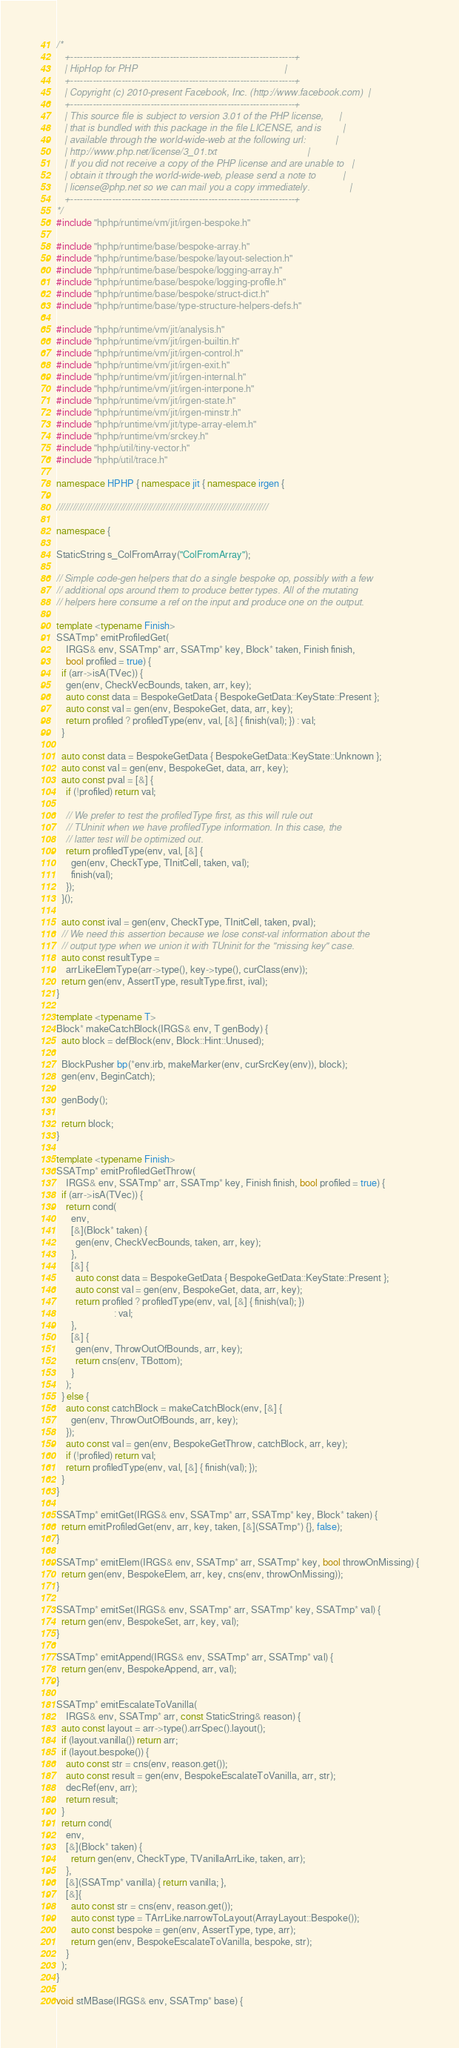<code> <loc_0><loc_0><loc_500><loc_500><_C++_>/*
   +----------------------------------------------------------------------+
   | HipHop for PHP                                                       |
   +----------------------------------------------------------------------+
   | Copyright (c) 2010-present Facebook, Inc. (http://www.facebook.com)  |
   +----------------------------------------------------------------------+
   | This source file is subject to version 3.01 of the PHP license,      |
   | that is bundled with this package in the file LICENSE, and is        |
   | available through the world-wide-web at the following url:           |
   | http://www.php.net/license/3_01.txt                                  |
   | If you did not receive a copy of the PHP license and are unable to   |
   | obtain it through the world-wide-web, please send a note to          |
   | license@php.net so we can mail you a copy immediately.               |
   +----------------------------------------------------------------------+
*/
#include "hphp/runtime/vm/jit/irgen-bespoke.h"

#include "hphp/runtime/base/bespoke-array.h"
#include "hphp/runtime/base/bespoke/layout-selection.h"
#include "hphp/runtime/base/bespoke/logging-array.h"
#include "hphp/runtime/base/bespoke/logging-profile.h"
#include "hphp/runtime/base/bespoke/struct-dict.h"
#include "hphp/runtime/base/type-structure-helpers-defs.h"

#include "hphp/runtime/vm/jit/analysis.h"
#include "hphp/runtime/vm/jit/irgen-builtin.h"
#include "hphp/runtime/vm/jit/irgen-control.h"
#include "hphp/runtime/vm/jit/irgen-exit.h"
#include "hphp/runtime/vm/jit/irgen-internal.h"
#include "hphp/runtime/vm/jit/irgen-interpone.h"
#include "hphp/runtime/vm/jit/irgen-state.h"
#include "hphp/runtime/vm/jit/irgen-minstr.h"
#include "hphp/runtime/vm/jit/type-array-elem.h"
#include "hphp/runtime/vm/srckey.h"
#include "hphp/util/tiny-vector.h"
#include "hphp/util/trace.h"

namespace HPHP { namespace jit { namespace irgen {

///////////////////////////////////////////////////////////////////////////////

namespace {

StaticString s_ColFromArray("ColFromArray");

// Simple code-gen helpers that do a single bespoke op, possibly with a few
// additional ops around them to produce better types. All of the mutating
// helpers here consume a ref on the input and produce one on the output.

template <typename Finish>
SSATmp* emitProfiledGet(
    IRGS& env, SSATmp* arr, SSATmp* key, Block* taken, Finish finish,
    bool profiled = true) {
  if (arr->isA(TVec)) {
    gen(env, CheckVecBounds, taken, arr, key);
    auto const data = BespokeGetData { BespokeGetData::KeyState::Present };
    auto const val = gen(env, BespokeGet, data, arr, key);
    return profiled ? profiledType(env, val, [&] { finish(val); }) : val;
  }

  auto const data = BespokeGetData { BespokeGetData::KeyState::Unknown };
  auto const val = gen(env, BespokeGet, data, arr, key);
  auto const pval = [&] {
    if (!profiled) return val;

    // We prefer to test the profiledType first, as this will rule out
    // TUninit when we have profiledType information. In this case, the
    // latter test will be optimized out.
    return profiledType(env, val, [&] {
      gen(env, CheckType, TInitCell, taken, val);
      finish(val);
    });
  }();

  auto const ival = gen(env, CheckType, TInitCell, taken, pval);
  // We need this assertion because we lose const-val information about the
  // output type when we union it with TUninit for the "missing key" case.
  auto const resultType =
    arrLikeElemType(arr->type(), key->type(), curClass(env));
  return gen(env, AssertType, resultType.first, ival);
}

template <typename T>
Block* makeCatchBlock(IRGS& env, T genBody) {
  auto block = defBlock(env, Block::Hint::Unused);

  BlockPusher bp(*env.irb, makeMarker(env, curSrcKey(env)), block);
  gen(env, BeginCatch);

  genBody();

  return block;
}

template <typename Finish>
SSATmp* emitProfiledGetThrow(
    IRGS& env, SSATmp* arr, SSATmp* key, Finish finish, bool profiled = true) {
  if (arr->isA(TVec)) {
    return cond(
      env,
      [&](Block* taken) {
        gen(env, CheckVecBounds, taken, arr, key);
      },
      [&] {
        auto const data = BespokeGetData { BespokeGetData::KeyState::Present };
        auto const val = gen(env, BespokeGet, data, arr, key);
        return profiled ? profiledType(env, val, [&] { finish(val); })
                        : val;
      },
      [&] {
        gen(env, ThrowOutOfBounds, arr, key);
        return cns(env, TBottom);
      }
    );
  } else {
    auto const catchBlock = makeCatchBlock(env, [&] {
      gen(env, ThrowOutOfBounds, arr, key);
    });
    auto const val = gen(env, BespokeGetThrow, catchBlock, arr, key);
    if (!profiled) return val;
    return profiledType(env, val, [&] { finish(val); });
  }
}

SSATmp* emitGet(IRGS& env, SSATmp* arr, SSATmp* key, Block* taken) {
  return emitProfiledGet(env, arr, key, taken, [&](SSATmp*) {}, false);
}

SSATmp* emitElem(IRGS& env, SSATmp* arr, SSATmp* key, bool throwOnMissing) {
  return gen(env, BespokeElem, arr, key, cns(env, throwOnMissing));
}

SSATmp* emitSet(IRGS& env, SSATmp* arr, SSATmp* key, SSATmp* val) {
  return gen(env, BespokeSet, arr, key, val);
}

SSATmp* emitAppend(IRGS& env, SSATmp* arr, SSATmp* val) {
  return gen(env, BespokeAppend, arr, val);
}

SSATmp* emitEscalateToVanilla(
    IRGS& env, SSATmp* arr, const StaticString& reason) {
  auto const layout = arr->type().arrSpec().layout();
  if (layout.vanilla()) return arr;
  if (layout.bespoke()) {
    auto const str = cns(env, reason.get());
    auto const result = gen(env, BespokeEscalateToVanilla, arr, str);
    decRef(env, arr);
    return result;
  }
  return cond(
    env,
    [&](Block* taken) {
      return gen(env, CheckType, TVanillaArrLike, taken, arr);
    },
    [&](SSATmp* vanilla) { return vanilla; },
    [&]{
      auto const str = cns(env, reason.get());
      auto const type = TArrLike.narrowToLayout(ArrayLayout::Bespoke());
      auto const bespoke = gen(env, AssertType, type, arr);
      return gen(env, BespokeEscalateToVanilla, bespoke, str);
    }
  );
}

void stMBase(IRGS& env, SSATmp* base) {</code> 